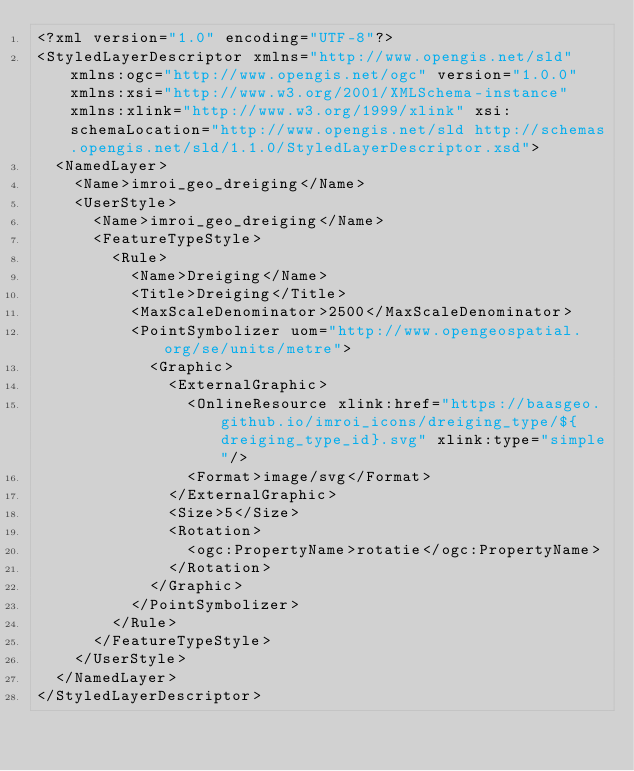<code> <loc_0><loc_0><loc_500><loc_500><_Scheme_><?xml version="1.0" encoding="UTF-8"?>
<StyledLayerDescriptor xmlns="http://www.opengis.net/sld" xmlns:ogc="http://www.opengis.net/ogc" version="1.0.0" xmlns:xsi="http://www.w3.org/2001/XMLSchema-instance" xmlns:xlink="http://www.w3.org/1999/xlink" xsi:schemaLocation="http://www.opengis.net/sld http://schemas.opengis.net/sld/1.1.0/StyledLayerDescriptor.xsd">
  <NamedLayer>
    <Name>imroi_geo_dreiging</Name>
    <UserStyle>
      <Name>imroi_geo_dreiging</Name>
      <FeatureTypeStyle>
        <Rule>
          <Name>Dreiging</Name>
          <Title>Dreiging</Title>
          <MaxScaleDenominator>2500</MaxScaleDenominator>
          <PointSymbolizer uom="http://www.opengeospatial.org/se/units/metre">
            <Graphic>
              <ExternalGraphic>
                <OnlineResource xlink:href="https://baasgeo.github.io/imroi_icons/dreiging_type/${dreiging_type_id}.svg" xlink:type="simple"/>
                <Format>image/svg</Format>
              </ExternalGraphic>
              <Size>5</Size>
              <Rotation>
                <ogc:PropertyName>rotatie</ogc:PropertyName>
              </Rotation>
            </Graphic>
          </PointSymbolizer>
        </Rule>
      </FeatureTypeStyle>
    </UserStyle>
  </NamedLayer>
</StyledLayerDescriptor>

</code> 